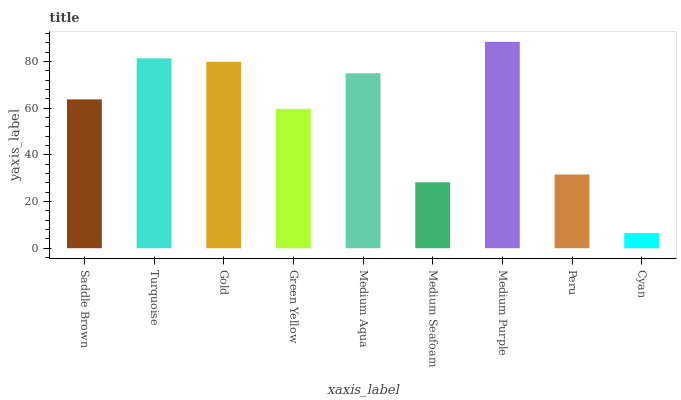Is Medium Purple the maximum?
Answer yes or no. Yes. Is Turquoise the minimum?
Answer yes or no. No. Is Turquoise the maximum?
Answer yes or no. No. Is Turquoise greater than Saddle Brown?
Answer yes or no. Yes. Is Saddle Brown less than Turquoise?
Answer yes or no. Yes. Is Saddle Brown greater than Turquoise?
Answer yes or no. No. Is Turquoise less than Saddle Brown?
Answer yes or no. No. Is Saddle Brown the high median?
Answer yes or no. Yes. Is Saddle Brown the low median?
Answer yes or no. Yes. Is Turquoise the high median?
Answer yes or no. No. Is Medium Seafoam the low median?
Answer yes or no. No. 